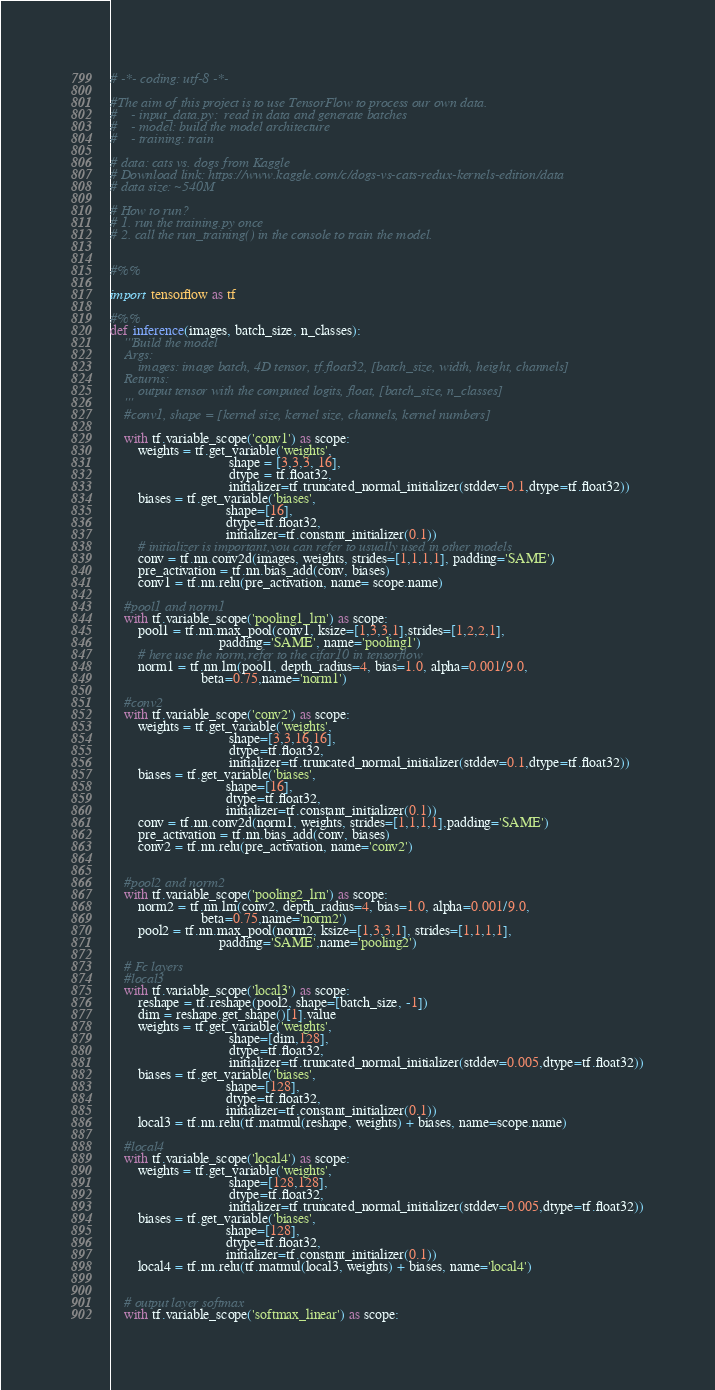<code> <loc_0><loc_0><loc_500><loc_500><_Python_># -*- coding: utf-8 -*-

#The aim of this project is to use TensorFlow to process our own data.
#    - input_data.py:  read in data and generate batches
#    - model: build the model architecture
#    - training: train

# data: cats vs. dogs from Kaggle
# Download link: https://www.kaggle.com/c/dogs-vs-cats-redux-kernels-edition/data
# data size: ~540M

# How to run?
# 1. run the training.py once
# 2. call the run_training() in the console to train the model.


#%%

import tensorflow as tf

#%%
def inference(images, batch_size, n_classes):
    '''Build the model
    Args:
        images: image batch, 4D tensor, tf.float32, [batch_size, width, height, channels]
    Returns:
        output tensor with the computed logits, float, [batch_size, n_classes]
    '''
    #conv1, shape = [kernel size, kernel size, channels, kernel numbers]
    
    with tf.variable_scope('conv1') as scope:
        weights = tf.get_variable('weights', 
                                  shape = [3,3,3, 16],
                                  dtype = tf.float32, 
                                  initializer=tf.truncated_normal_initializer(stddev=0.1,dtype=tf.float32))
        biases = tf.get_variable('biases', 
                                 shape=[16],
                                 dtype=tf.float32,
                                 initializer=tf.constant_initializer(0.1))
        # initializer is important,you can refer to usually used in other models
        conv = tf.nn.conv2d(images, weights, strides=[1,1,1,1], padding='SAME')
        pre_activation = tf.nn.bias_add(conv, biases)
        conv1 = tf.nn.relu(pre_activation, name= scope.name)
    
    #pool1 and norm1   
    with tf.variable_scope('pooling1_lrn') as scope:
        pool1 = tf.nn.max_pool(conv1, ksize=[1,3,3,1],strides=[1,2,2,1],
                               padding='SAME', name='pooling1')
        # here use the norm,refer to the cifar10 in tensorflow
        norm1 = tf.nn.lrn(pool1, depth_radius=4, bias=1.0, alpha=0.001/9.0,
                          beta=0.75,name='norm1')
    
    #conv2
    with tf.variable_scope('conv2') as scope:
        weights = tf.get_variable('weights',
                                  shape=[3,3,16,16],
                                  dtype=tf.float32,
                                  initializer=tf.truncated_normal_initializer(stddev=0.1,dtype=tf.float32))
        biases = tf.get_variable('biases',
                                 shape=[16], 
                                 dtype=tf.float32,
                                 initializer=tf.constant_initializer(0.1))
        conv = tf.nn.conv2d(norm1, weights, strides=[1,1,1,1],padding='SAME')
        pre_activation = tf.nn.bias_add(conv, biases)
        conv2 = tf.nn.relu(pre_activation, name='conv2')
    
    
    #pool2 and norm2
    with tf.variable_scope('pooling2_lrn') as scope:
        norm2 = tf.nn.lrn(conv2, depth_radius=4, bias=1.0, alpha=0.001/9.0,
                          beta=0.75,name='norm2')
        pool2 = tf.nn.max_pool(norm2, ksize=[1,3,3,1], strides=[1,1,1,1],
                               padding='SAME',name='pooling2')
    
    # Fc layers
    #local3
    with tf.variable_scope('local3') as scope:
        reshape = tf.reshape(pool2, shape=[batch_size, -1])
        dim = reshape.get_shape()[1].value
        weights = tf.get_variable('weights',
                                  shape=[dim,128],
                                  dtype=tf.float32,
                                  initializer=tf.truncated_normal_initializer(stddev=0.005,dtype=tf.float32))
        biases = tf.get_variable('biases',
                                 shape=[128],
                                 dtype=tf.float32, 
                                 initializer=tf.constant_initializer(0.1))
        local3 = tf.nn.relu(tf.matmul(reshape, weights) + biases, name=scope.name)    
    
    #local4
    with tf.variable_scope('local4') as scope:
        weights = tf.get_variable('weights',
                                  shape=[128,128],
                                  dtype=tf.float32, 
                                  initializer=tf.truncated_normal_initializer(stddev=0.005,dtype=tf.float32))
        biases = tf.get_variable('biases',
                                 shape=[128],
                                 dtype=tf.float32,
                                 initializer=tf.constant_initializer(0.1))
        local4 = tf.nn.relu(tf.matmul(local3, weights) + biases, name='local4')
     
        
    # output layer softmax
    with tf.variable_scope('softmax_linear') as scope:</code> 